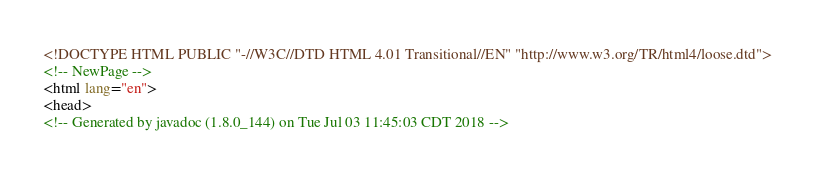<code> <loc_0><loc_0><loc_500><loc_500><_HTML_><!DOCTYPE HTML PUBLIC "-//W3C//DTD HTML 4.01 Transitional//EN" "http://www.w3.org/TR/html4/loose.dtd">
<!-- NewPage -->
<html lang="en">
<head>
<!-- Generated by javadoc (1.8.0_144) on Tue Jul 03 11:45:03 CDT 2018 --></code> 